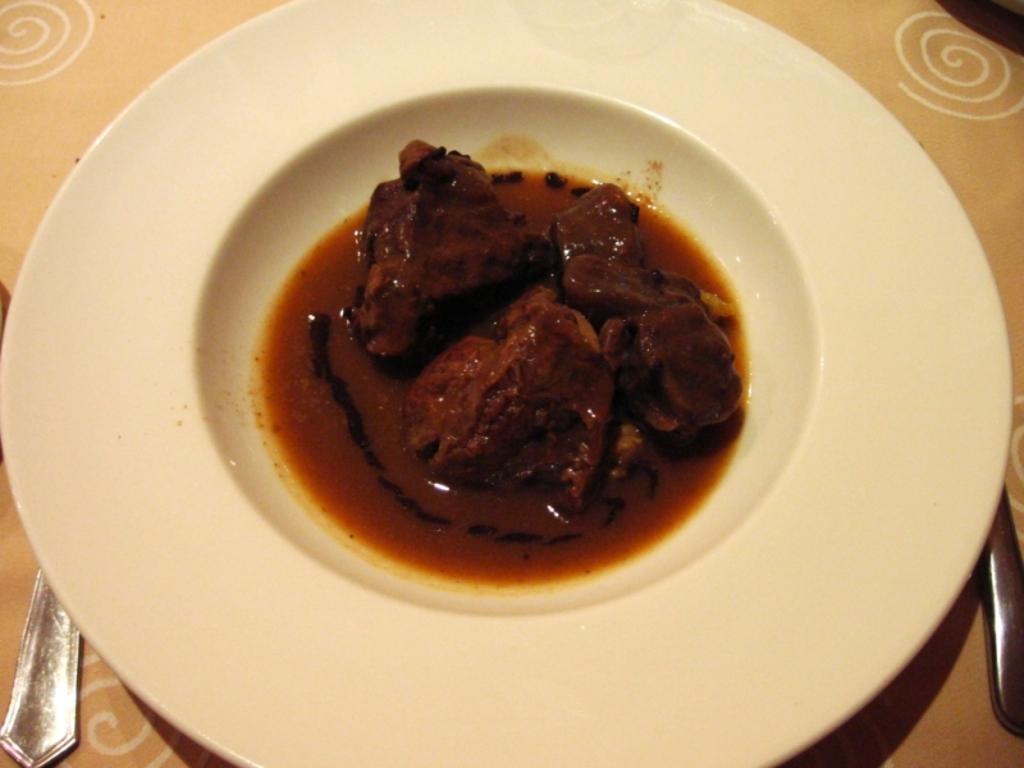Describe this image in one or two sentences. In this image we can see a plate with some food and spoons on the table. 